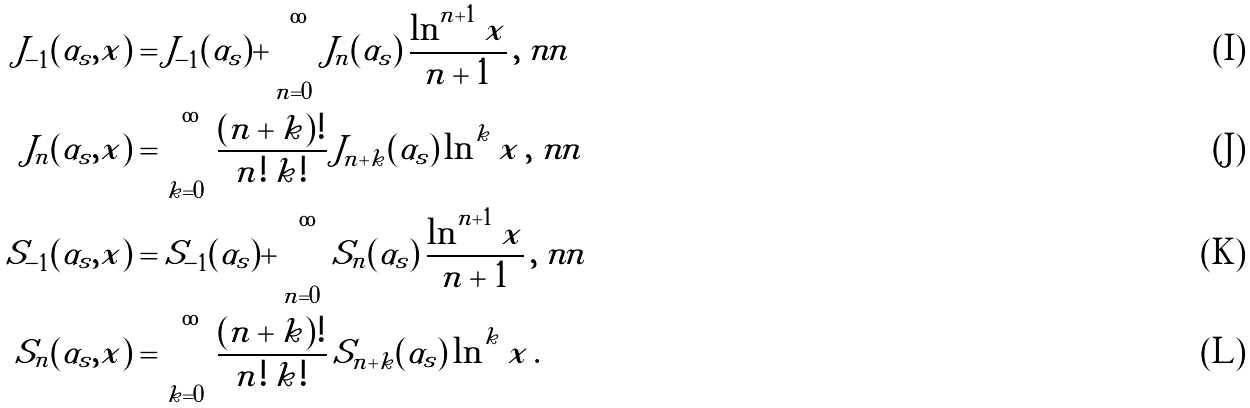<formula> <loc_0><loc_0><loc_500><loc_500>J _ { - 1 } ( \alpha _ { s } , x ) & = J _ { - 1 } ( \alpha _ { s } ) + \sum _ { n = 0 } ^ { \infty } J _ { n } ( \alpha _ { s } ) \, \frac { \ln ^ { n + 1 } x } { n + 1 } \, , \ n n \\ J _ { n } ( \alpha _ { s } , x ) & = \sum _ { k = 0 } ^ { \infty } \frac { ( n + k ) ! } { n ! \, k ! } \, J _ { n + k } ( \alpha _ { s } ) \, \ln ^ { k } x \, , \ n n \\ S _ { - 1 } ( \alpha _ { s } , x ) & = S _ { - 1 } ( \alpha _ { s } ) + \sum _ { n = 0 } ^ { \infty } S _ { n } ( \alpha _ { s } ) \, \frac { \ln ^ { n + 1 } x } { n + 1 } \, , \ n n \\ S _ { n } ( \alpha _ { s } , x ) & = \sum _ { k = 0 } ^ { \infty } \frac { ( n + k ) ! } { n ! \, k ! } \, S _ { n + k } ( \alpha _ { s } ) \, \ln ^ { k } x \, .</formula> 